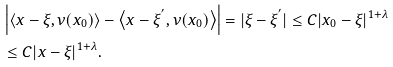Convert formula to latex. <formula><loc_0><loc_0><loc_500><loc_500>& \left | \left \langle x - \xi , \nu ( x _ { 0 } ) \right \rangle - \left \langle x - \xi ^ { ^ { \prime } } , \nu ( x _ { 0 } ) \right \rangle \right | = | \xi - \xi ^ { ^ { \prime } } | \leq C | x _ { 0 } - \xi | ^ { 1 + \lambda } \\ & \leq C | x - \xi | ^ { 1 + \lambda } .</formula> 